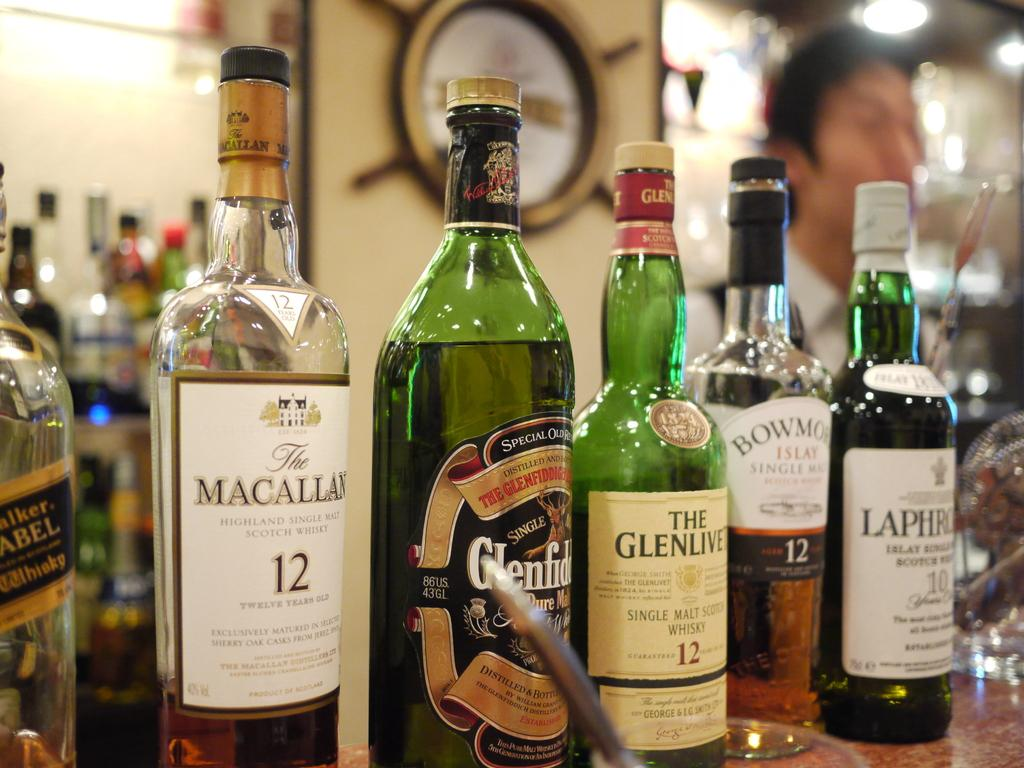<image>
Share a concise interpretation of the image provided. Many bottles of whiskey are lined up, including Macallan 12 year Scotch whiskey. 